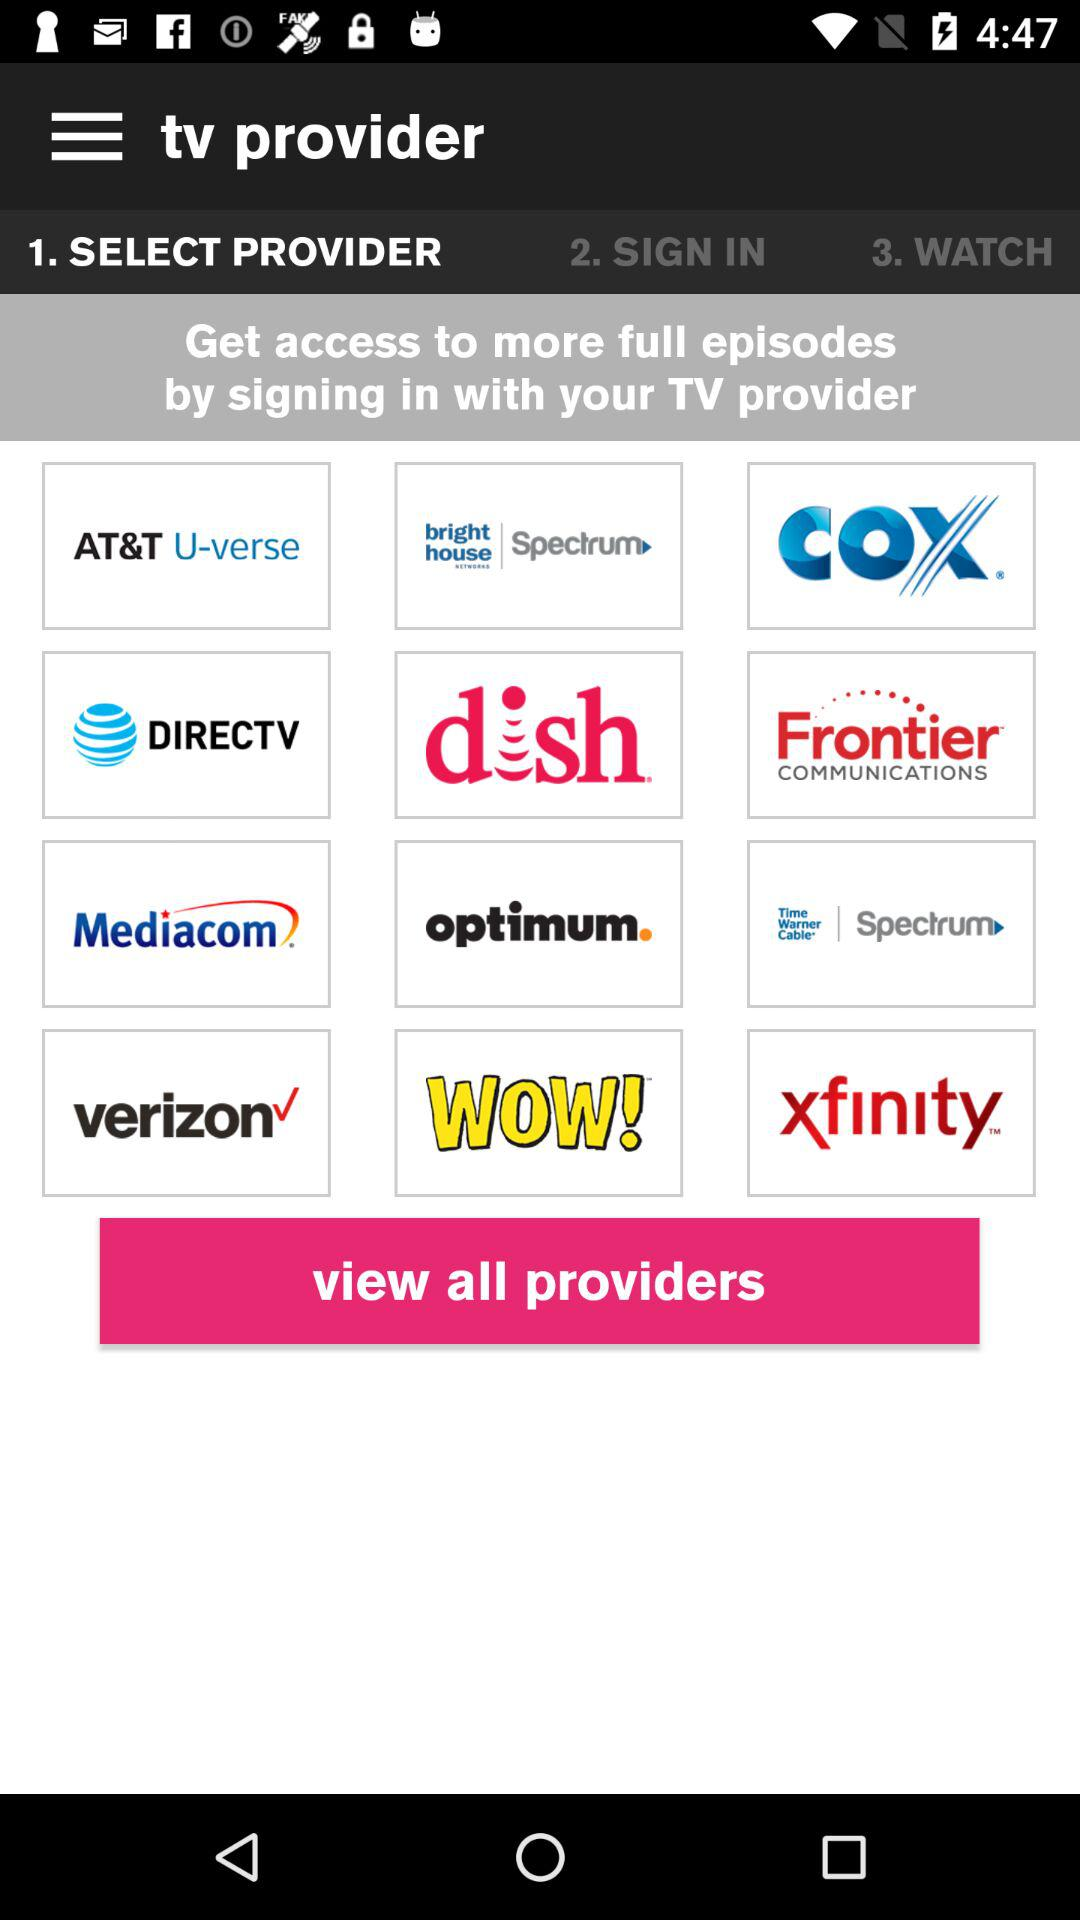What are the different providers available? The different providers available are "AT&T U-verse", "bright house Spectrum", "COX", "DIRECTV", "dish", "Frontier COMMUNICATIONS", "Mediacom", "optimum", "Time Warner Cable Spectrum", "verizon", "WOW!" and "xfinity". 